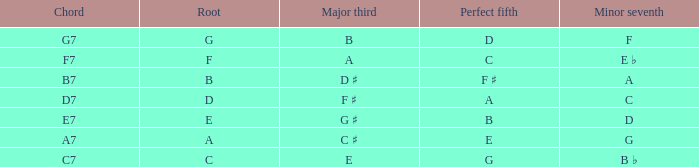What is the chord of f with a minor seventh? G7. 